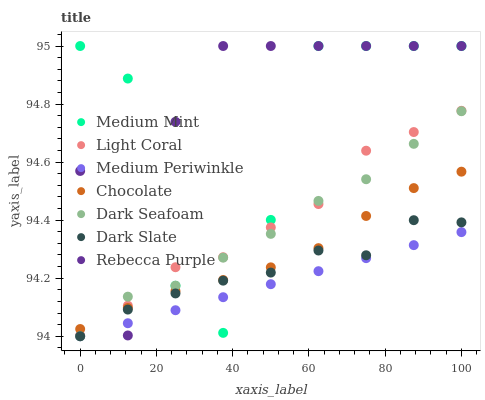Does Medium Periwinkle have the minimum area under the curve?
Answer yes or no. Yes. Does Rebecca Purple have the maximum area under the curve?
Answer yes or no. Yes. Does Chocolate have the minimum area under the curve?
Answer yes or no. No. Does Chocolate have the maximum area under the curve?
Answer yes or no. No. Is Medium Periwinkle the smoothest?
Answer yes or no. Yes. Is Medium Mint the roughest?
Answer yes or no. Yes. Is Chocolate the smoothest?
Answer yes or no. No. Is Chocolate the roughest?
Answer yes or no. No. Does Medium Periwinkle have the lowest value?
Answer yes or no. Yes. Does Chocolate have the lowest value?
Answer yes or no. No. Does Rebecca Purple have the highest value?
Answer yes or no. Yes. Does Chocolate have the highest value?
Answer yes or no. No. Is Medium Periwinkle less than Chocolate?
Answer yes or no. Yes. Is Chocolate greater than Medium Periwinkle?
Answer yes or no. Yes. Does Medium Mint intersect Dark Seafoam?
Answer yes or no. Yes. Is Medium Mint less than Dark Seafoam?
Answer yes or no. No. Is Medium Mint greater than Dark Seafoam?
Answer yes or no. No. Does Medium Periwinkle intersect Chocolate?
Answer yes or no. No. 